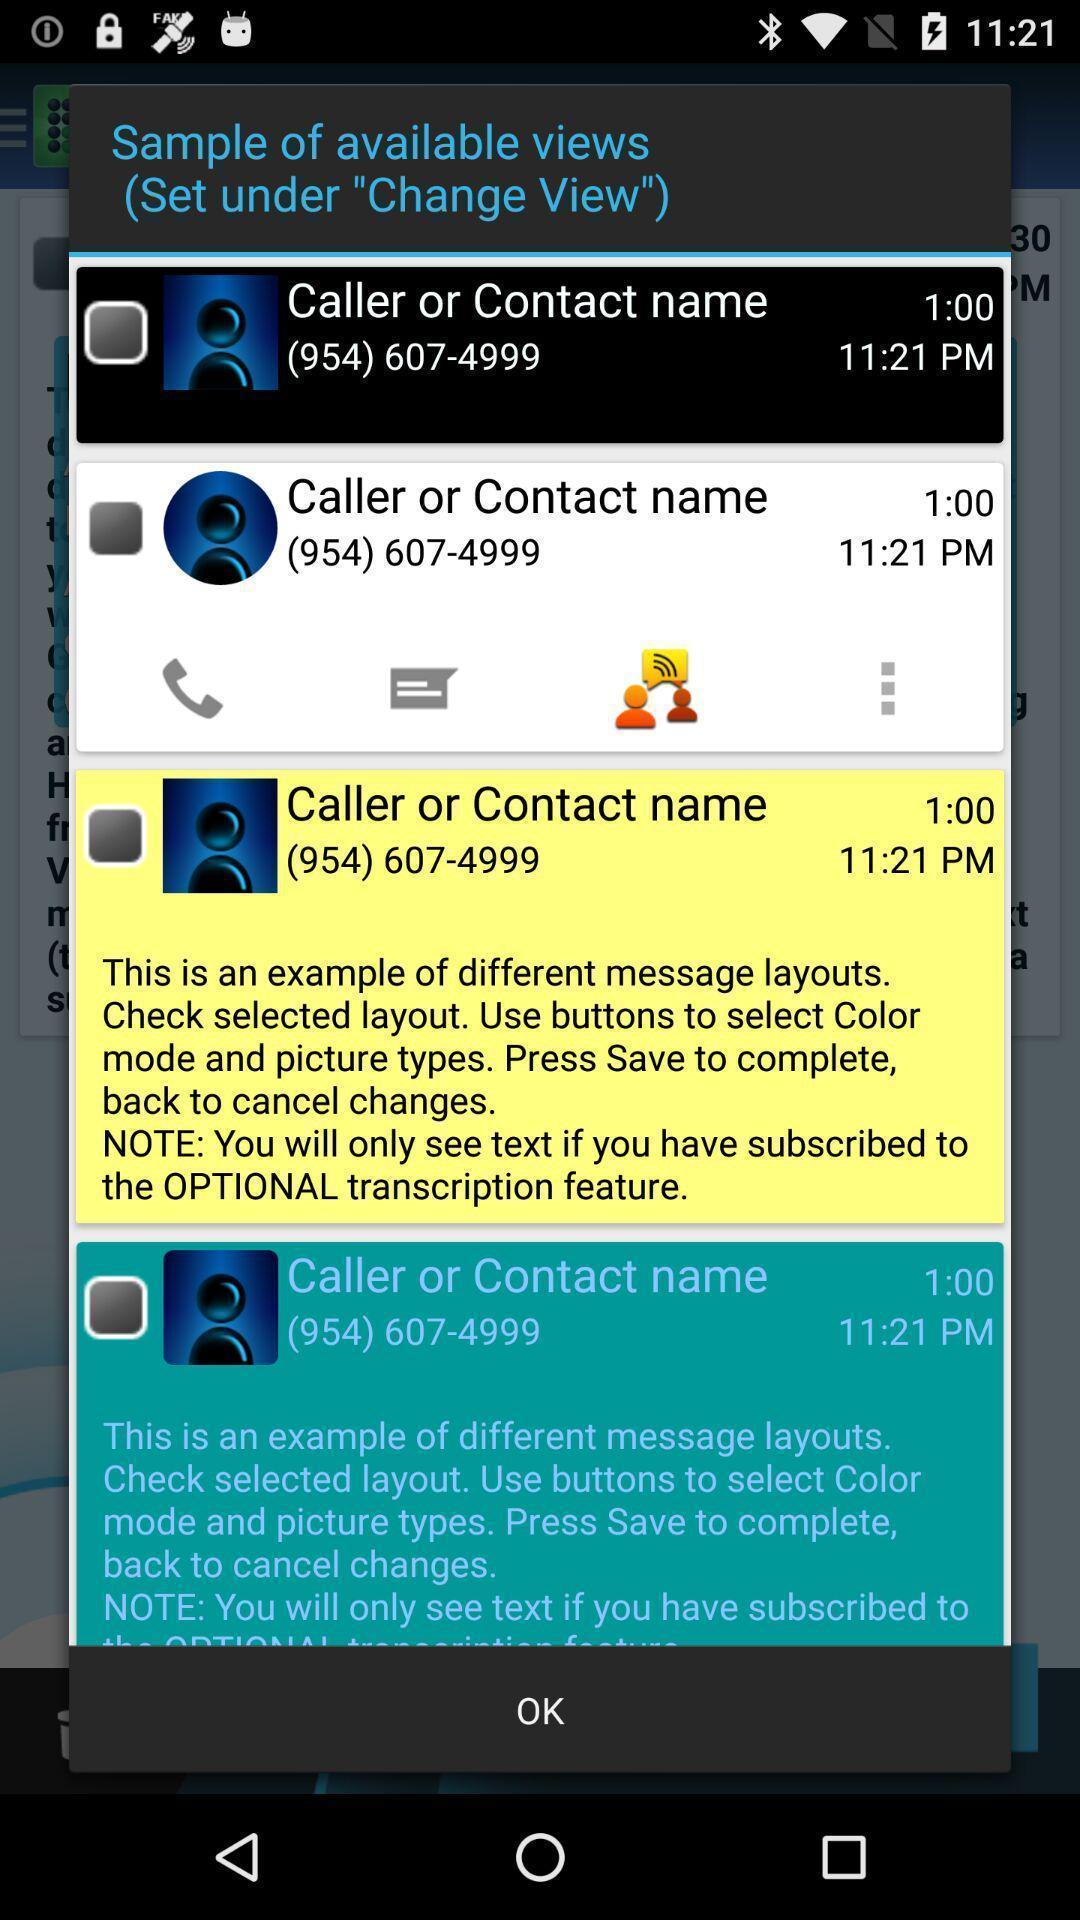What details can you identify in this image? Pop-up shows sample of available views of messages. 